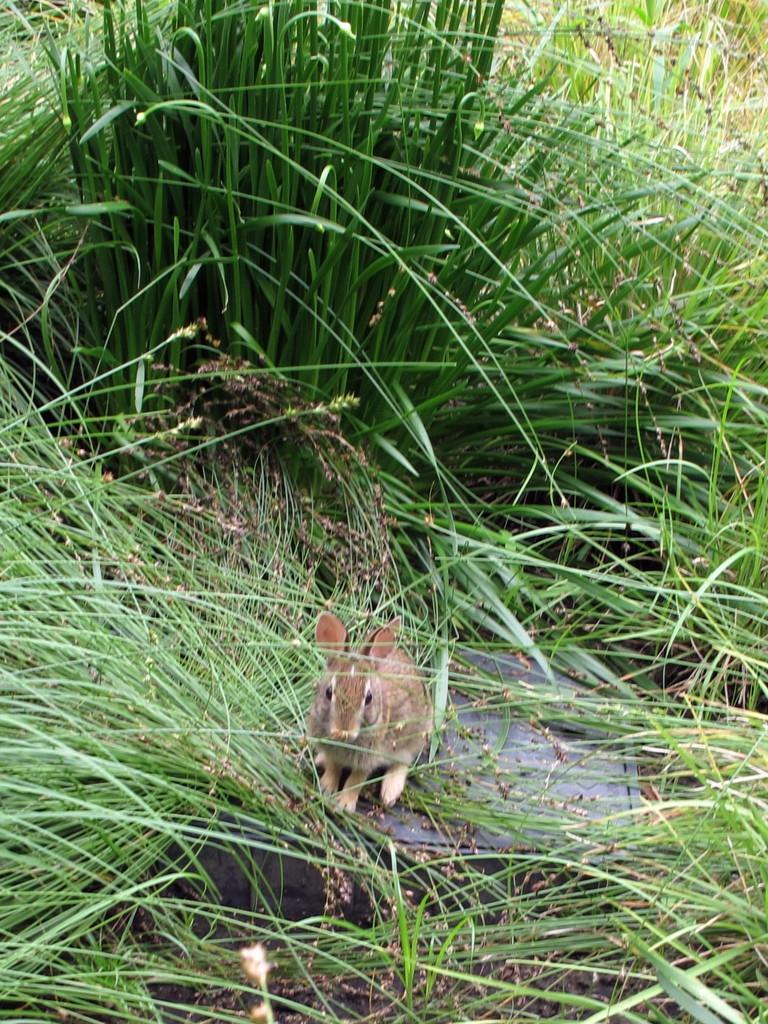What type of creature is in the image? There is an animal in the image. Can you describe the coloring of the animal? The animal has brown and cream colors. Where is the animal located in the image? The animal is on a black box. What type of natural environment is visible in the image? There is green grass visible in the image. What type of gold object is the animal holding in the image? There is no gold object present in the image, and the animal is not holding anything. 